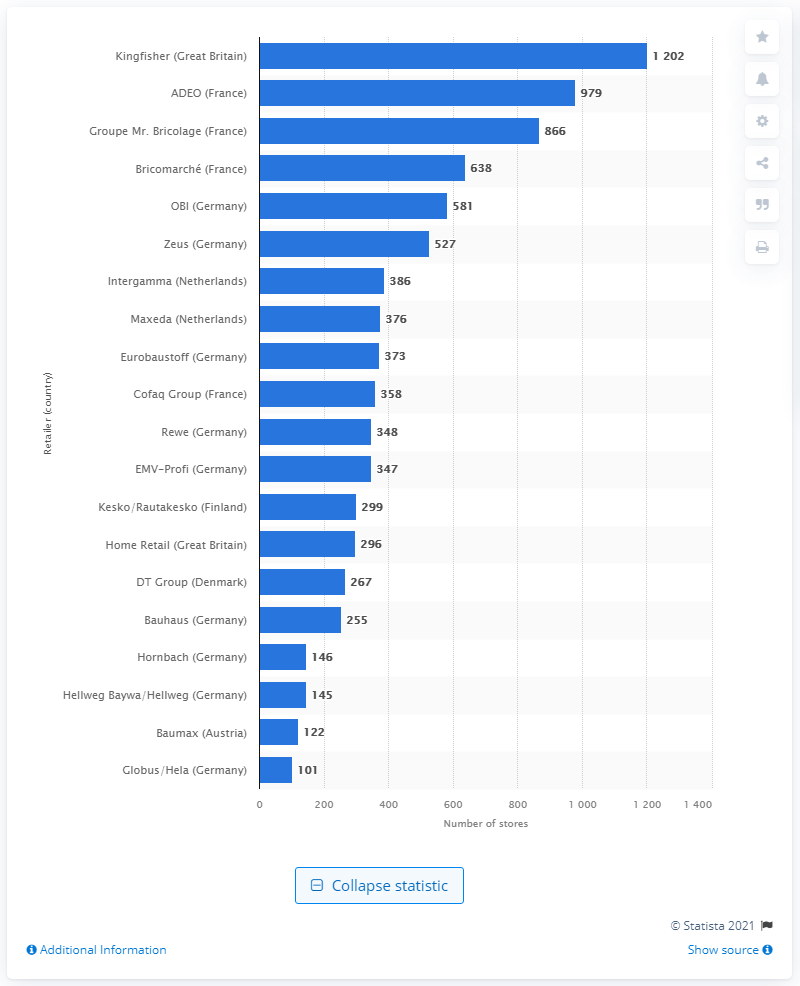What insight can we gain about the home improvement market in Germany from this graphic? This graphic reveals that Germany had a competitive home improvement retail market in 2014, with multiple players like OBI, Zeus, Eurobaustoff, Rewe, EMV-Profi, Bauhaus, Hornbach, and Hellweg Baywa/Hellweg represented in the chart. It indicates a fragmented market with several strong brands, demonstrating Germany's robust demand for home improvement products and services. 